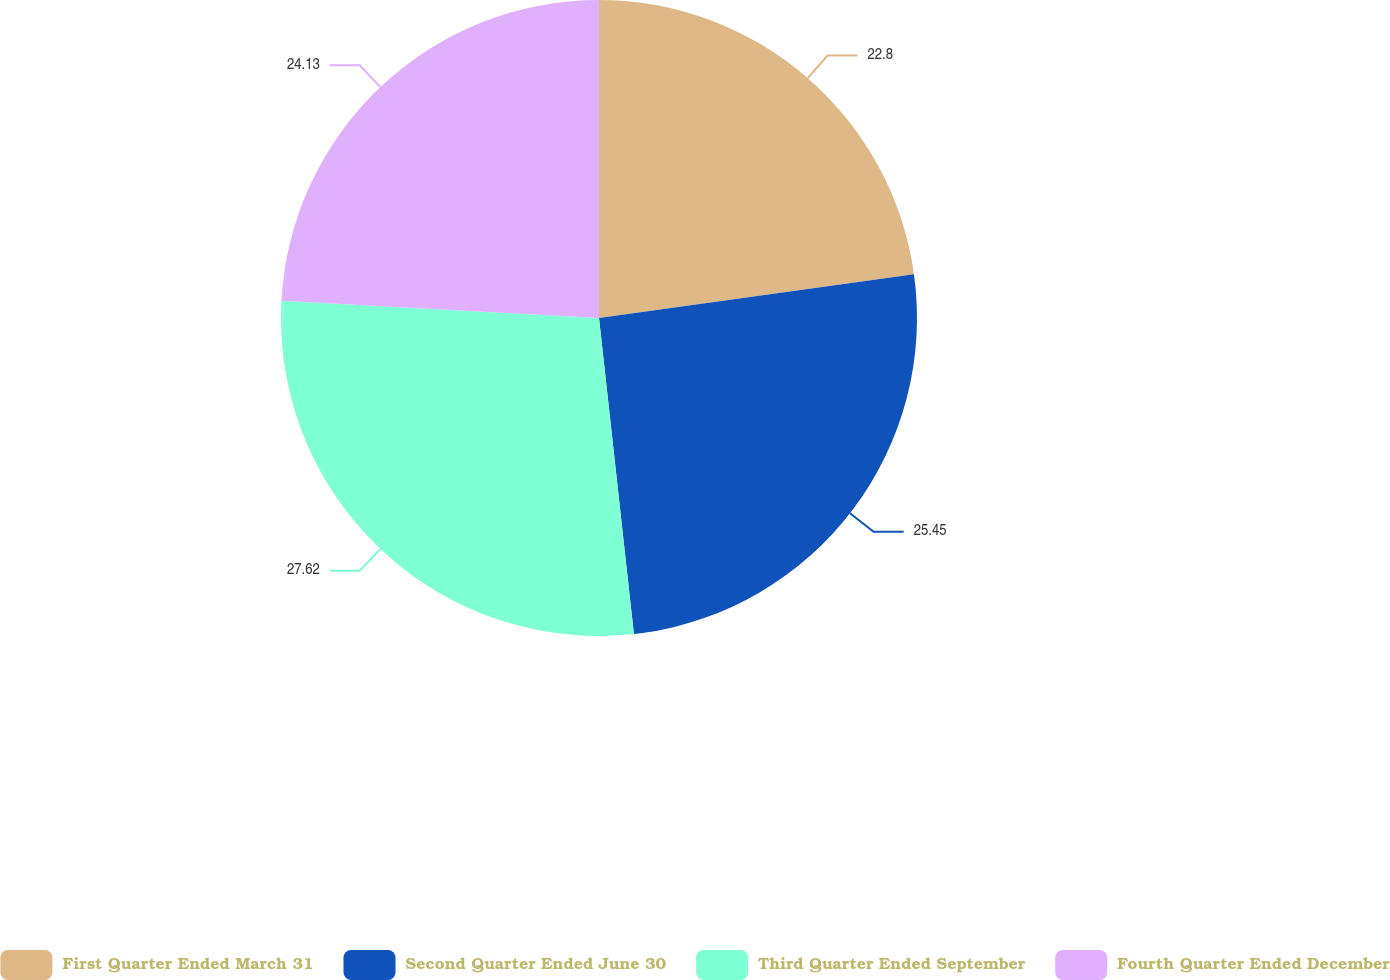<chart> <loc_0><loc_0><loc_500><loc_500><pie_chart><fcel>First Quarter Ended March 31<fcel>Second Quarter Ended June 30<fcel>Third Quarter Ended September<fcel>Fourth Quarter Ended December<nl><fcel>22.8%<fcel>25.45%<fcel>27.62%<fcel>24.13%<nl></chart> 